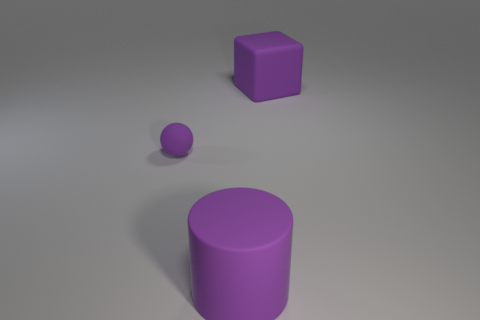Add 2 tiny cyan shiny cylinders. How many objects exist? 5 Subtract all balls. How many objects are left? 2 Subtract 0 yellow balls. How many objects are left? 3 Subtract all large purple cylinders. Subtract all small balls. How many objects are left? 1 Add 3 large purple cubes. How many large purple cubes are left? 4 Add 2 tiny cyan blocks. How many tiny cyan blocks exist? 2 